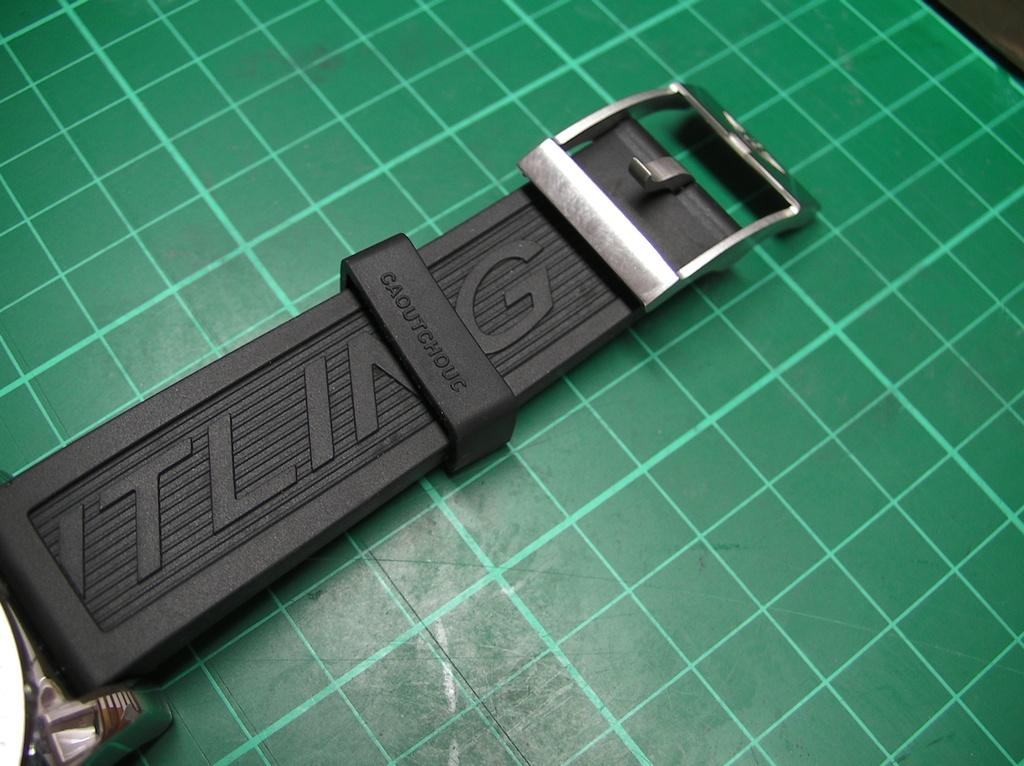<image>
Summarize the visual content of the image. A black watch wrist strap with  Caoutchouc written on it. 